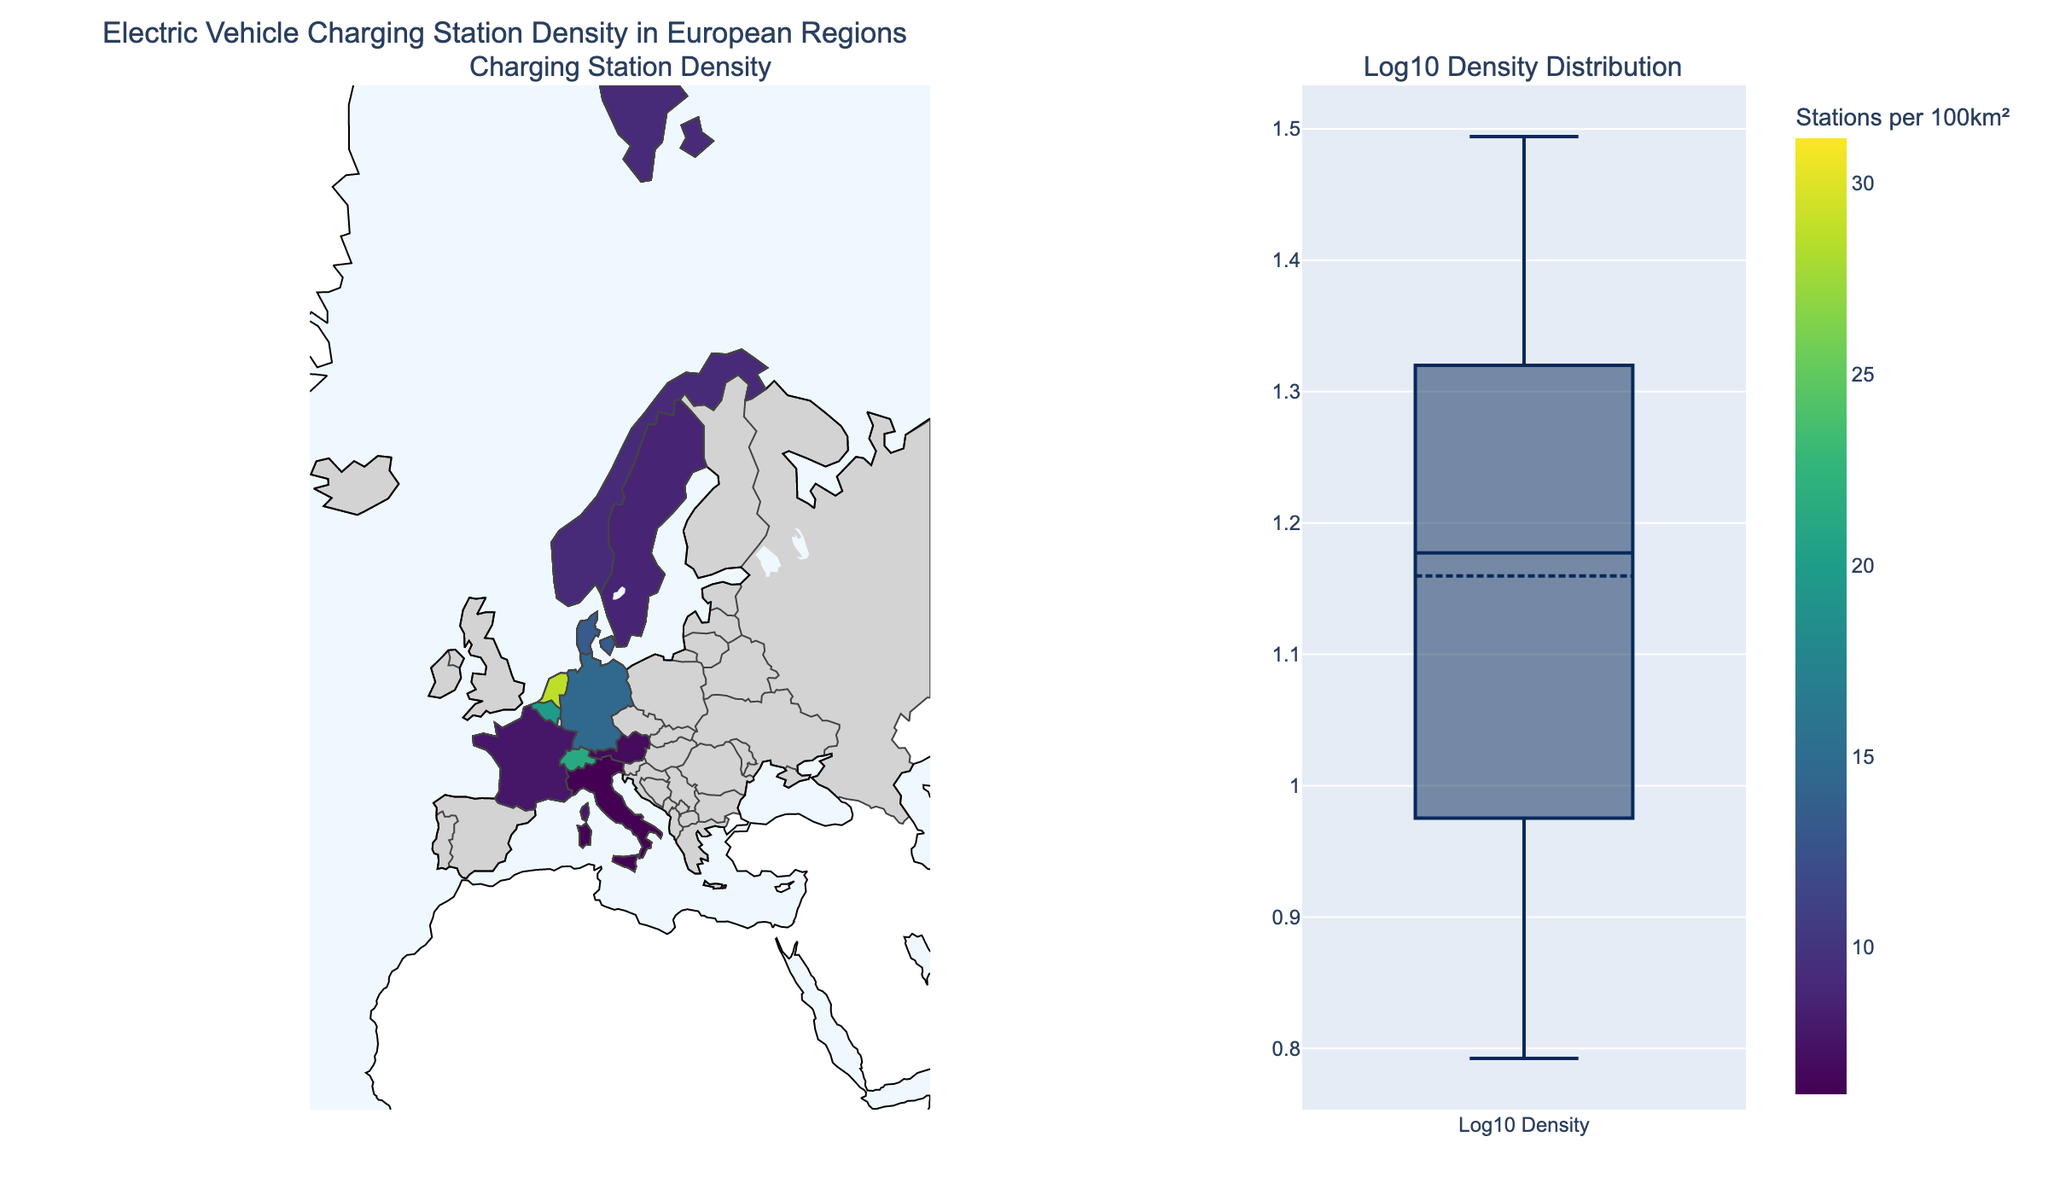What is the title of the plot? The title is prominently displayed at the top of the figure, indicating the overall topic of the visualization. It helps in quickly identifying what the plot is about.
Answer: Electric Vehicle Charging Station Density in European Regions Which country has the highest density of charging stations in any region? By examining the choropleth map on the left, one can identify the region with the highest value. The text and color details help distinguish the specific region.
Answer: Belgium (Brussels-Capital Region) How does the density of charging stations in North Holland compare with that in Stockholm County? Locate both North Holland and Stockholm County on the choropleth map. Compare their shading and reference the values displayed. North Holland has 25.3 stations per 100km², while Stockholm County has 11.3 stations per 100km².
Answer: North Holland has a higher density What is the color representing the highest density of charging stations? Observe the color bar titled "Stations per 100km²" and identify the darkest or most intense color at the upper end of the scale.
Answer: Dark green What is the median log10 density of charging stations based on the box plot? Examine the box plot on the right. The median log10 density is represented by the horizontal line inside the box. The exact value has to be read off the axis or inferred from the plot.
Answer: Approximately 1.1 Which region in Germany has a higher density of charging stations, Bavaria or Baden-Württemberg? Locate both Bavaria and Baden-Württemberg on the choropleth map and compare their color intensity or specific values given. Bavaria has 12.1 stations per 100km², while Baden-Württemberg has 14.5 stations per 100km².
Answer: Baden-Württemberg Calculate the average density of charging stations in the listed regions of Austria. Identify the regions of Austria (Vienna and Tyrol), sum their charging station densities, and divide by the number of regions. (20.5 + 6.9) / 2 = 13.7.
Answer: 13.7 How does the log10 density distribution help in understanding the data better? The box plot for log10 density distribution normalizes the data, making it easier to compare regions with vastly different densities by reducing skewness and highlighting the general spread and any outliers.
Answer: It reduces skewness and highlights spread and outliers Are there any outliers in the log10 density distribution of charging stations? In the box plot, outliers are typically small circles outside the main box whisker. Identify if any such outliers are present.
Answer: Yes Which region in France has a higher density of charging stations, Île-de-France or Auvergne-Rhône-Alpes? Locate both regions on the map or refer to their respective values. Île-de-France has 15.6 stations per 100km², while Auvergne-Rhône-Alpes has 7.8 stations per 100km².
Answer: Île-de-France 